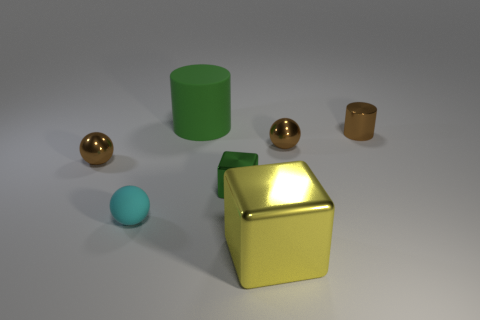Add 1 large yellow metal blocks. How many objects exist? 8 Subtract all green blocks. How many blocks are left? 1 Subtract all tiny cyan balls. How many balls are left? 2 Subtract all small purple shiny spheres. Subtract all big green things. How many objects are left? 6 Add 3 brown metal balls. How many brown metal balls are left? 5 Add 7 big objects. How many big objects exist? 9 Subtract 2 brown balls. How many objects are left? 5 Subtract all cylinders. How many objects are left? 5 Subtract 3 spheres. How many spheres are left? 0 Subtract all blue balls. Subtract all green cubes. How many balls are left? 3 